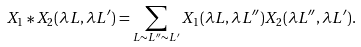<formula> <loc_0><loc_0><loc_500><loc_500>X _ { 1 } * X _ { 2 } ( \lambda L , \lambda L ^ { \prime } ) = \sum _ { L \sim L ^ { \prime \prime } \sim L ^ { \prime } } X _ { 1 } ( \lambda L , \lambda L ^ { \prime \prime } ) X _ { 2 } ( \lambda L ^ { \prime \prime } , \lambda L ^ { \prime } ) .</formula> 